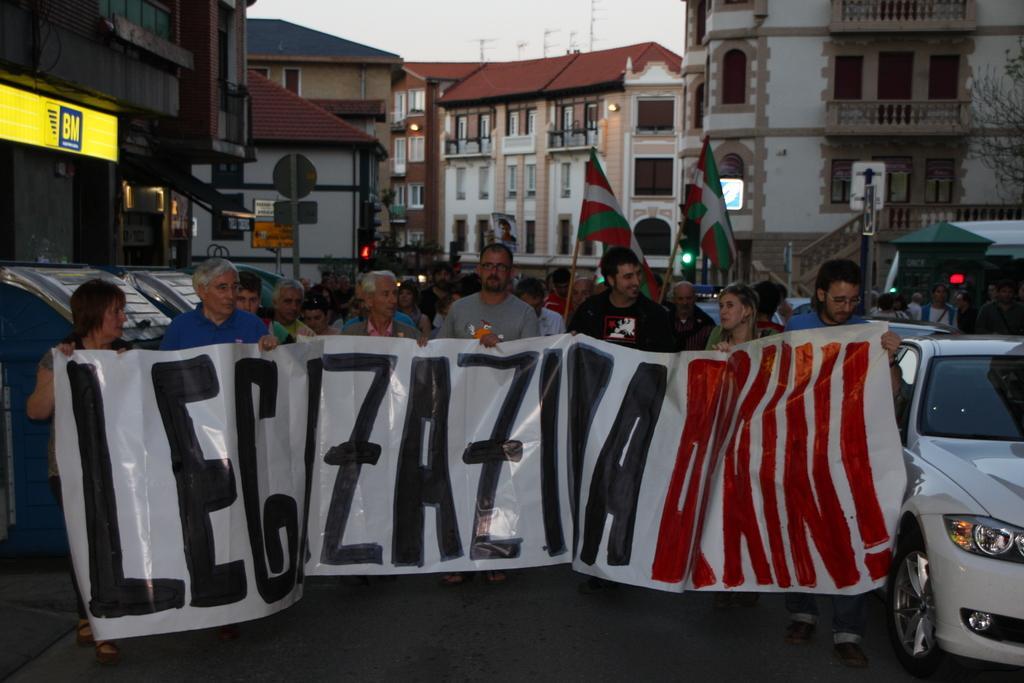How would you summarize this image in a sentence or two? In the image we can see there are many people wearing clothes. This is a banner, vehicle, headlights of the vehicle, flag, building and the windows of the building, fence and a sky. This is a road. 